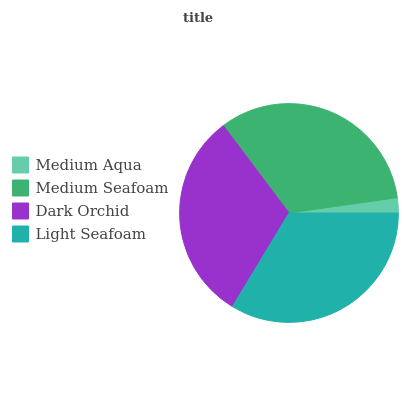Is Medium Aqua the minimum?
Answer yes or no. Yes. Is Light Seafoam the maximum?
Answer yes or no. Yes. Is Medium Seafoam the minimum?
Answer yes or no. No. Is Medium Seafoam the maximum?
Answer yes or no. No. Is Medium Seafoam greater than Medium Aqua?
Answer yes or no. Yes. Is Medium Aqua less than Medium Seafoam?
Answer yes or no. Yes. Is Medium Aqua greater than Medium Seafoam?
Answer yes or no. No. Is Medium Seafoam less than Medium Aqua?
Answer yes or no. No. Is Medium Seafoam the high median?
Answer yes or no. Yes. Is Dark Orchid the low median?
Answer yes or no. Yes. Is Medium Aqua the high median?
Answer yes or no. No. Is Light Seafoam the low median?
Answer yes or no. No. 